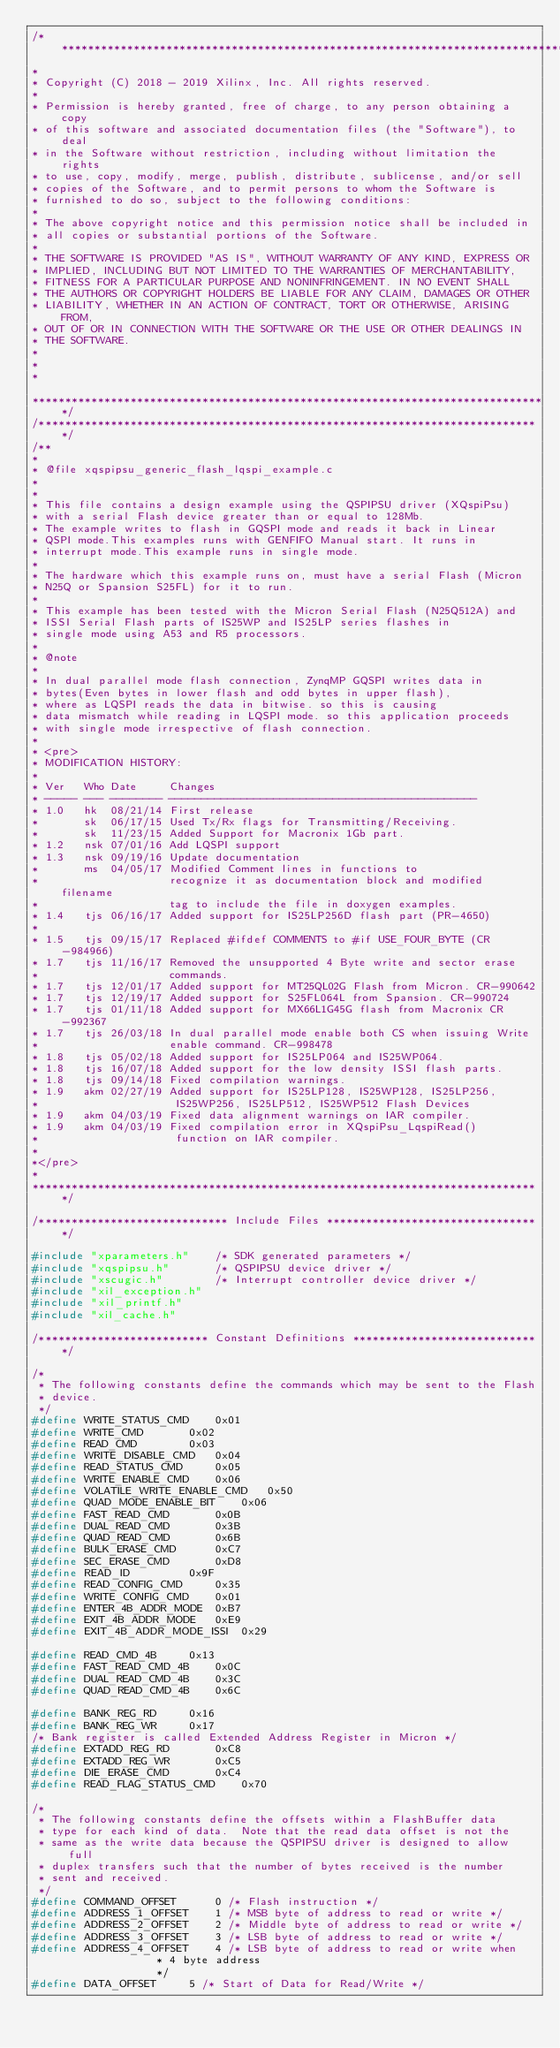Convert code to text. <code><loc_0><loc_0><loc_500><loc_500><_C_>/******************************************************************************
*
* Copyright (C) 2018 - 2019 Xilinx, Inc. All rights reserved.
*
* Permission is hereby granted, free of charge, to any person obtaining a copy
* of this software and associated documentation files (the "Software"), to deal
* in the Software without restriction, including without limitation the rights
* to use, copy, modify, merge, publish, distribute, sublicense, and/or sell
* copies of the Software, and to permit persons to whom the Software is
* furnished to do so, subject to the following conditions:
*
* The above copyright notice and this permission notice shall be included in
* all copies or substantial portions of the Software.
*
* THE SOFTWARE IS PROVIDED "AS IS", WITHOUT WARRANTY OF ANY KIND, EXPRESS OR
* IMPLIED, INCLUDING BUT NOT LIMITED TO THE WARRANTIES OF MERCHANTABILITY,
* FITNESS FOR A PARTICULAR PURPOSE AND NONINFRINGEMENT. IN NO EVENT SHALL
* THE AUTHORS OR COPYRIGHT HOLDERS BE LIABLE FOR ANY CLAIM, DAMAGES OR OTHER
* LIABILITY, WHETHER IN AN ACTION OF CONTRACT, TORT OR OTHERWISE, ARISING FROM,
* OUT OF OR IN CONNECTION WITH THE SOFTWARE OR THE USE OR OTHER DEALINGS IN
* THE SOFTWARE.
*
*
*

*******************************************************************************/
/*****************************************************************************/
/**
*
* @file xqspipsu_generic_flash_lqspi_example.c
*
*
* This file contains a design example using the QSPIPSU driver (XQspiPsu)
* with a serial Flash device greater than or equal to 128Mb.
* The example writes to flash in GQSPI mode and reads it back in Linear
* QSPI mode.This examples runs with GENFIFO Manual start. It runs in
* interrupt mode.This example runs in single mode.
*
* The hardware which this example runs on, must have a serial Flash (Micron
* N25Q or Spansion S25FL) for it to run.
*
* This example has been tested with the Micron Serial Flash (N25Q512A) and
* ISSI Serial Flash parts of IS25WP and IS25LP series flashes in
* single mode using A53 and R5 processors.
*
* @note
*
* In dual parallel mode flash connection, ZynqMP GQSPI writes data in
* bytes(Even bytes in lower flash and odd bytes in upper flash),
* where as LQSPI reads the data in bitwise. so this is causing
* data mismatch while reading in LQSPI mode. so this application proceeds
* with single mode irrespective of flash connection.
*
* <pre>
* MODIFICATION HISTORY:
*
* Ver   Who Date     Changes
* ----- --- -------- -----------------------------------------------
* 1.0   hk  08/21/14 First release
*       sk  06/17/15 Used Tx/Rx flags for Transmitting/Receiving.
*		sk  11/23/15 Added Support for Macronix 1Gb part.
* 1.2	nsk 07/01/16 Add LQSPI support
* 1.3	nsk 09/19/16 Update documentation
*       ms  04/05/17 Modified Comment lines in functions to
*                    recognize it as documentation block and modified filename
*                    tag to include the file in doxygen examples.
* 1.4	tjs	06/16/17 Added support for IS25LP256D flash part (PR-4650)
*
* 1.5	tjs 09/15/17 Replaced #ifdef COMMENTS to #if USE_FOUR_BYTE (CR-984966)
* 1.7   tjs 11/16/17 Removed the unsupported 4 Byte write and sector erase
*                    commands.
* 1.7	tjs	12/01/17 Added support for MT25QL02G Flash from Micron. CR-990642
* 1.7	tjs 12/19/17 Added support for S25FL064L from Spansion. CR-990724
* 1.7	tjs 01/11/18 Added support for MX66L1G45G flash from Macronix CR-992367
* 1.7	tjs 26/03/18 In dual parallel mode enable both CS when issuing Write
*		     		 enable command. CR-998478
* 1.8	tjs 05/02/18 Added support for IS25LP064 and IS25WP064.
* 1.8	tjs 16/07/18 Added support for the low density ISSI flash parts.
* 1.8	tjs 09/14/18 Fixed compilation warnings.
* 1.9   akm 02/27/19 Added support for IS25LP128, IS25WP128, IS25LP256,
*                     IS25WP256, IS25LP512, IS25WP512 Flash Devices
* 1.9   akm 04/03/19 Fixed data alignment warnings on IAR compiler.
* 1.9   akm 04/03/19 Fixed compilation error in XQspiPsu_LqspiRead()
*                     function on IAR compiler.
*
*</pre>
*
******************************************************************************/

/***************************** Include Files *********************************/

#include "xparameters.h"	/* SDK generated parameters */
#include "xqspipsu.h"		/* QSPIPSU device driver */
#include "xscugic.h"		/* Interrupt controller device driver */
#include "xil_exception.h"
#include "xil_printf.h"
#include "xil_cache.h"

/************************** Constant Definitions *****************************/

/*
 * The following constants define the commands which may be sent to the Flash
 * device.
 */
#define WRITE_STATUS_CMD	0x01
#define WRITE_CMD		0x02
#define READ_CMD		0x03
#define WRITE_DISABLE_CMD	0x04
#define READ_STATUS_CMD		0x05
#define WRITE_ENABLE_CMD	0x06
#define VOLATILE_WRITE_ENABLE_CMD	0x50
#define QUAD_MODE_ENABLE_BIT	0x06
#define FAST_READ_CMD		0x0B
#define DUAL_READ_CMD		0x3B
#define QUAD_READ_CMD		0x6B
#define BULK_ERASE_CMD		0xC7
#define	SEC_ERASE_CMD		0xD8
#define READ_ID			0x9F
#define READ_CONFIG_CMD		0x35
#define WRITE_CONFIG_CMD	0x01
#define ENTER_4B_ADDR_MODE	0xB7
#define EXIT_4B_ADDR_MODE	0xE9
#define EXIT_4B_ADDR_MODE_ISSI	0x29

#define READ_CMD_4B		0x13
#define FAST_READ_CMD_4B	0x0C
#define DUAL_READ_CMD_4B	0x3C
#define QUAD_READ_CMD_4B	0x6C

#define BANK_REG_RD		0x16
#define BANK_REG_WR		0x17
/* Bank register is called Extended Address Register in Micron */
#define EXTADD_REG_RD		0xC8
#define EXTADD_REG_WR		0xC5
#define	DIE_ERASE_CMD		0xC4
#define READ_FLAG_STATUS_CMD	0x70

/*
 * The following constants define the offsets within a FlashBuffer data
 * type for each kind of data.  Note that the read data offset is not the
 * same as the write data because the QSPIPSU driver is designed to allow full
 * duplex transfers such that the number of bytes received is the number
 * sent and received.
 */
#define COMMAND_OFFSET		0 /* Flash instruction */
#define ADDRESS_1_OFFSET	1 /* MSB byte of address to read or write */
#define ADDRESS_2_OFFSET	2 /* Middle byte of address to read or write */
#define ADDRESS_3_OFFSET	3 /* LSB byte of address to read or write */
#define ADDRESS_4_OFFSET	4 /* LSB byte of address to read or write when
				   * 4 byte address
				   */
#define DATA_OFFSET		5 /* Start of Data for Read/Write */</code> 